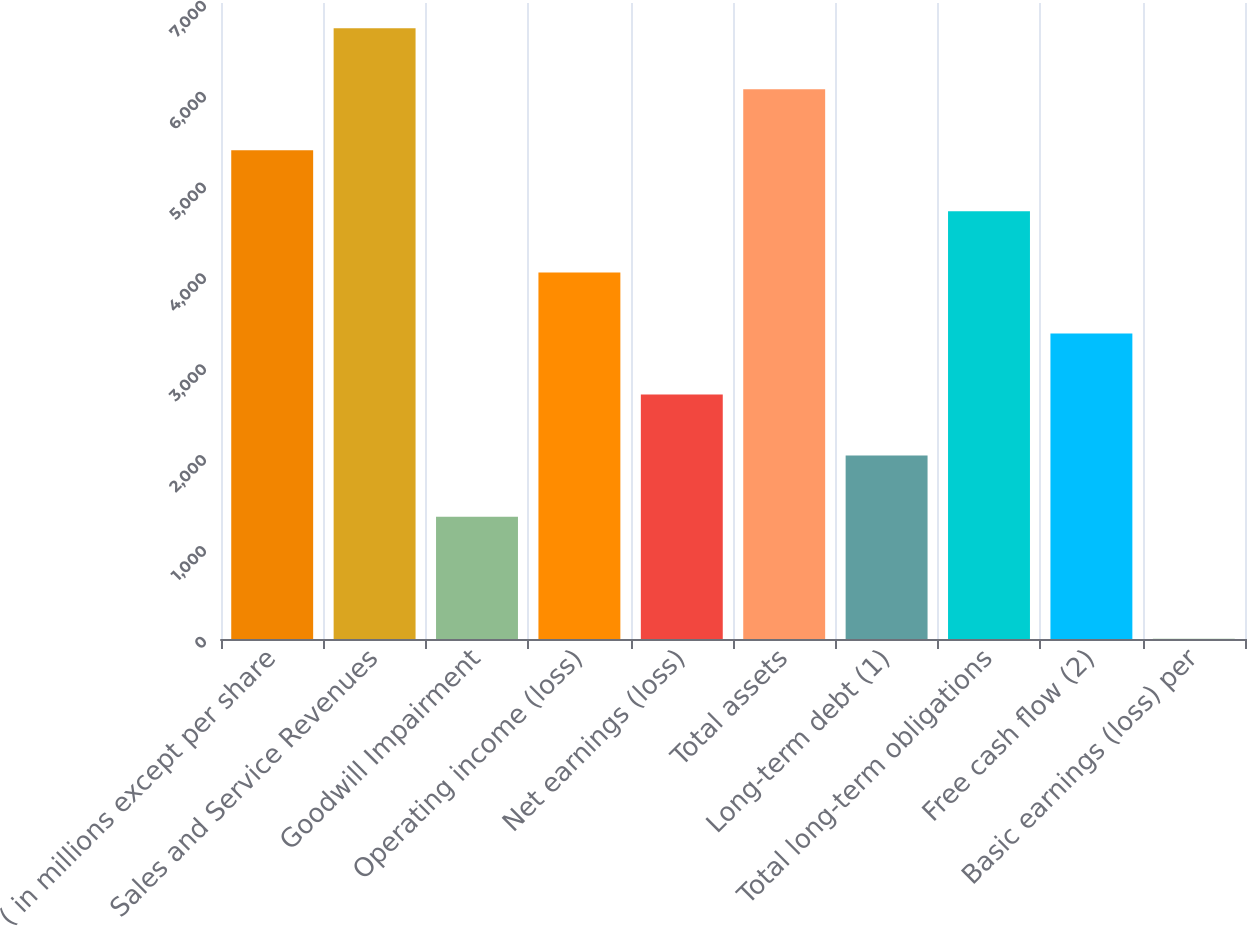Convert chart to OTSL. <chart><loc_0><loc_0><loc_500><loc_500><bar_chart><fcel>( in millions except per share<fcel>Sales and Service Revenues<fcel>Goodwill Impairment<fcel>Operating income (loss)<fcel>Net earnings (loss)<fcel>Total assets<fcel>Long-term debt (1)<fcel>Total long-term obligations<fcel>Free cash flow (2)<fcel>Basic earnings (loss) per<nl><fcel>5378.93<fcel>6723<fcel>1346.81<fcel>4034.89<fcel>2690.85<fcel>6050.95<fcel>2018.83<fcel>4706.91<fcel>3362.87<fcel>2.77<nl></chart> 